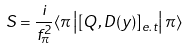<formula> <loc_0><loc_0><loc_500><loc_500>S = \frac { i } { f _ { \pi } ^ { 2 } } \langle \pi \left | \left [ Q , D ( y ) \right ] _ { e . t } \right | \pi \rangle</formula> 